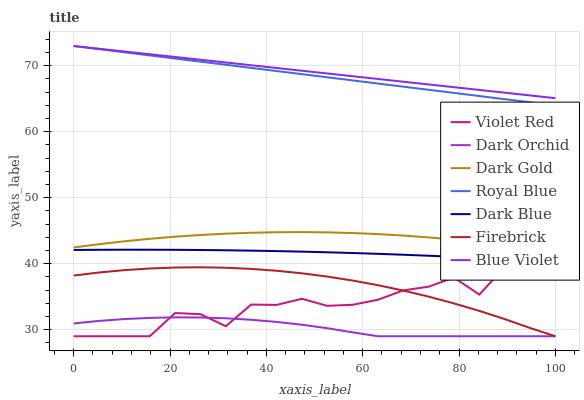Does Dark Blue have the minimum area under the curve?
Answer yes or no. No. Does Dark Blue have the maximum area under the curve?
Answer yes or no. No. Is Dark Blue the smoothest?
Answer yes or no. No. Is Dark Blue the roughest?
Answer yes or no. No. Does Dark Blue have the lowest value?
Answer yes or no. No. Does Dark Blue have the highest value?
Answer yes or no. No. Is Dark Gold less than Royal Blue?
Answer yes or no. Yes. Is Dark Gold greater than Violet Red?
Answer yes or no. Yes. Does Dark Gold intersect Royal Blue?
Answer yes or no. No. 